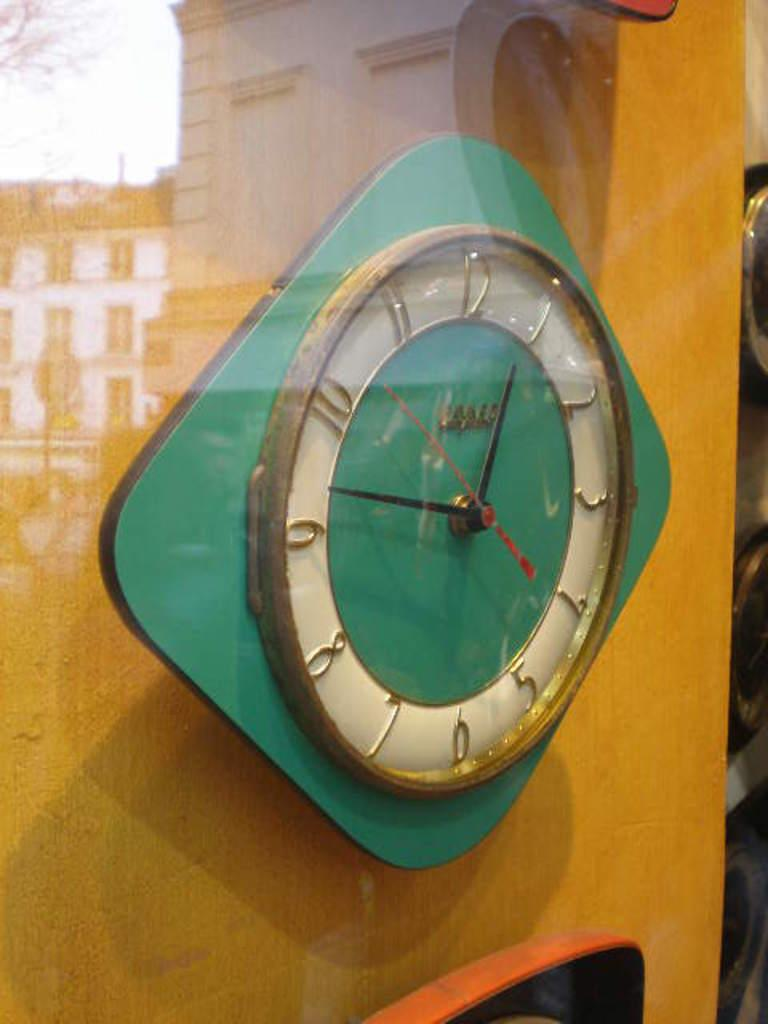<image>
Render a clear and concise summary of the photo. Green and white clock which has the hands on number 1 and 9. 